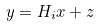Convert formula to latex. <formula><loc_0><loc_0><loc_500><loc_500>y = H _ { i } x + z</formula> 